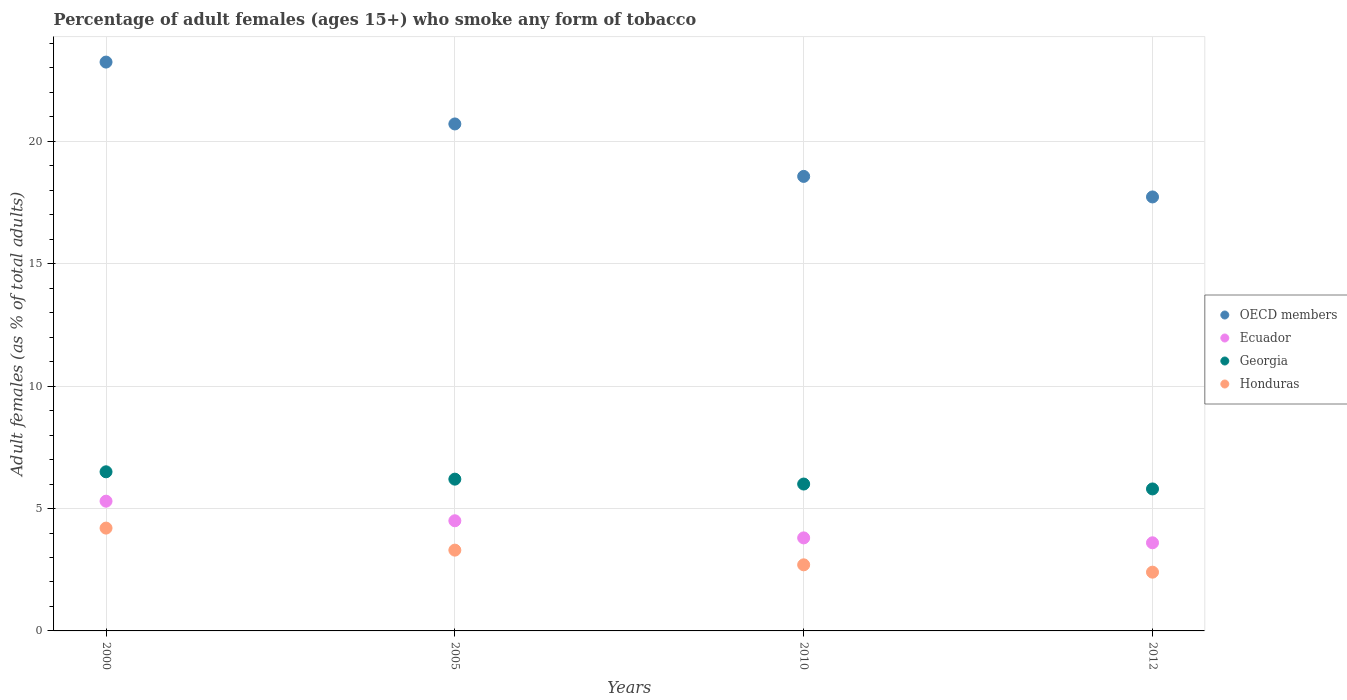How many different coloured dotlines are there?
Offer a terse response. 4. What is the percentage of adult females who smoke in Ecuador in 2010?
Ensure brevity in your answer.  3.8. Across all years, what is the minimum percentage of adult females who smoke in Honduras?
Ensure brevity in your answer.  2.4. In which year was the percentage of adult females who smoke in Honduras maximum?
Provide a short and direct response. 2000. In which year was the percentage of adult females who smoke in Ecuador minimum?
Ensure brevity in your answer.  2012. What is the total percentage of adult females who smoke in OECD members in the graph?
Offer a very short reply. 80.24. What is the difference between the percentage of adult females who smoke in Ecuador in 2000 and that in 2005?
Your response must be concise. 0.8. What is the difference between the percentage of adult females who smoke in OECD members in 2005 and the percentage of adult females who smoke in Ecuador in 2012?
Your answer should be compact. 17.11. What is the average percentage of adult females who smoke in Honduras per year?
Provide a short and direct response. 3.15. In the year 2012, what is the difference between the percentage of adult females who smoke in Ecuador and percentage of adult females who smoke in Georgia?
Give a very brief answer. -2.2. What is the ratio of the percentage of adult females who smoke in Honduras in 2010 to that in 2012?
Provide a succinct answer. 1.13. Is the percentage of adult females who smoke in Georgia in 2010 less than that in 2012?
Give a very brief answer. No. Is the difference between the percentage of adult females who smoke in Ecuador in 2005 and 2010 greater than the difference between the percentage of adult females who smoke in Georgia in 2005 and 2010?
Provide a short and direct response. Yes. What is the difference between the highest and the second highest percentage of adult females who smoke in Ecuador?
Give a very brief answer. 0.8. What is the difference between the highest and the lowest percentage of adult females who smoke in Georgia?
Your answer should be compact. 0.7. In how many years, is the percentage of adult females who smoke in OECD members greater than the average percentage of adult females who smoke in OECD members taken over all years?
Your response must be concise. 2. Is the sum of the percentage of adult females who smoke in Ecuador in 2005 and 2012 greater than the maximum percentage of adult females who smoke in Georgia across all years?
Your answer should be compact. Yes. Is it the case that in every year, the sum of the percentage of adult females who smoke in Honduras and percentage of adult females who smoke in Ecuador  is greater than the sum of percentage of adult females who smoke in OECD members and percentage of adult females who smoke in Georgia?
Make the answer very short. No. Is the percentage of adult females who smoke in Honduras strictly greater than the percentage of adult females who smoke in Ecuador over the years?
Ensure brevity in your answer.  No. Is the percentage of adult females who smoke in Honduras strictly less than the percentage of adult females who smoke in Ecuador over the years?
Your answer should be very brief. Yes. How many years are there in the graph?
Your answer should be very brief. 4. What is the difference between two consecutive major ticks on the Y-axis?
Your answer should be very brief. 5. Does the graph contain grids?
Your answer should be compact. Yes. How are the legend labels stacked?
Your response must be concise. Vertical. What is the title of the graph?
Provide a succinct answer. Percentage of adult females (ages 15+) who smoke any form of tobacco. What is the label or title of the X-axis?
Make the answer very short. Years. What is the label or title of the Y-axis?
Your answer should be very brief. Adult females (as % of total adults). What is the Adult females (as % of total adults) of OECD members in 2000?
Give a very brief answer. 23.24. What is the Adult females (as % of total adults) of Honduras in 2000?
Ensure brevity in your answer.  4.2. What is the Adult females (as % of total adults) of OECD members in 2005?
Offer a terse response. 20.71. What is the Adult females (as % of total adults) in Ecuador in 2005?
Provide a succinct answer. 4.5. What is the Adult females (as % of total adults) of Georgia in 2005?
Offer a terse response. 6.2. What is the Adult females (as % of total adults) in OECD members in 2010?
Your response must be concise. 18.57. What is the Adult females (as % of total adults) in Georgia in 2010?
Provide a succinct answer. 6. What is the Adult females (as % of total adults) of Honduras in 2010?
Provide a succinct answer. 2.7. What is the Adult females (as % of total adults) of OECD members in 2012?
Offer a very short reply. 17.73. What is the Adult females (as % of total adults) of Georgia in 2012?
Provide a short and direct response. 5.8. Across all years, what is the maximum Adult females (as % of total adults) of OECD members?
Provide a short and direct response. 23.24. Across all years, what is the maximum Adult females (as % of total adults) of Ecuador?
Your response must be concise. 5.3. Across all years, what is the minimum Adult females (as % of total adults) of OECD members?
Offer a very short reply. 17.73. Across all years, what is the minimum Adult females (as % of total adults) of Honduras?
Keep it short and to the point. 2.4. What is the total Adult females (as % of total adults) in OECD members in the graph?
Offer a terse response. 80.24. What is the total Adult females (as % of total adults) in Honduras in the graph?
Provide a succinct answer. 12.6. What is the difference between the Adult females (as % of total adults) of OECD members in 2000 and that in 2005?
Provide a short and direct response. 2.53. What is the difference between the Adult females (as % of total adults) of Ecuador in 2000 and that in 2005?
Offer a terse response. 0.8. What is the difference between the Adult females (as % of total adults) of OECD members in 2000 and that in 2010?
Give a very brief answer. 4.67. What is the difference between the Adult females (as % of total adults) of Ecuador in 2000 and that in 2010?
Your response must be concise. 1.5. What is the difference between the Adult females (as % of total adults) of Georgia in 2000 and that in 2010?
Your answer should be compact. 0.5. What is the difference between the Adult females (as % of total adults) of OECD members in 2000 and that in 2012?
Keep it short and to the point. 5.51. What is the difference between the Adult females (as % of total adults) of Honduras in 2000 and that in 2012?
Offer a very short reply. 1.8. What is the difference between the Adult females (as % of total adults) of OECD members in 2005 and that in 2010?
Ensure brevity in your answer.  2.14. What is the difference between the Adult females (as % of total adults) in Georgia in 2005 and that in 2010?
Ensure brevity in your answer.  0.2. What is the difference between the Adult females (as % of total adults) in OECD members in 2005 and that in 2012?
Make the answer very short. 2.98. What is the difference between the Adult females (as % of total adults) of Ecuador in 2005 and that in 2012?
Provide a succinct answer. 0.9. What is the difference between the Adult females (as % of total adults) in Georgia in 2005 and that in 2012?
Offer a terse response. 0.4. What is the difference between the Adult females (as % of total adults) in OECD members in 2010 and that in 2012?
Your answer should be compact. 0.84. What is the difference between the Adult females (as % of total adults) in Ecuador in 2010 and that in 2012?
Give a very brief answer. 0.2. What is the difference between the Adult females (as % of total adults) of OECD members in 2000 and the Adult females (as % of total adults) of Ecuador in 2005?
Your answer should be compact. 18.74. What is the difference between the Adult females (as % of total adults) in OECD members in 2000 and the Adult females (as % of total adults) in Georgia in 2005?
Offer a terse response. 17.04. What is the difference between the Adult females (as % of total adults) of OECD members in 2000 and the Adult females (as % of total adults) of Honduras in 2005?
Provide a short and direct response. 19.94. What is the difference between the Adult females (as % of total adults) of Ecuador in 2000 and the Adult females (as % of total adults) of Honduras in 2005?
Your answer should be compact. 2. What is the difference between the Adult females (as % of total adults) of OECD members in 2000 and the Adult females (as % of total adults) of Ecuador in 2010?
Your answer should be compact. 19.44. What is the difference between the Adult females (as % of total adults) in OECD members in 2000 and the Adult females (as % of total adults) in Georgia in 2010?
Offer a terse response. 17.24. What is the difference between the Adult females (as % of total adults) of OECD members in 2000 and the Adult females (as % of total adults) of Honduras in 2010?
Your answer should be compact. 20.54. What is the difference between the Adult females (as % of total adults) of Ecuador in 2000 and the Adult females (as % of total adults) of Honduras in 2010?
Give a very brief answer. 2.6. What is the difference between the Adult females (as % of total adults) of OECD members in 2000 and the Adult females (as % of total adults) of Ecuador in 2012?
Offer a very short reply. 19.64. What is the difference between the Adult females (as % of total adults) of OECD members in 2000 and the Adult females (as % of total adults) of Georgia in 2012?
Keep it short and to the point. 17.44. What is the difference between the Adult females (as % of total adults) in OECD members in 2000 and the Adult females (as % of total adults) in Honduras in 2012?
Your response must be concise. 20.84. What is the difference between the Adult females (as % of total adults) of Ecuador in 2000 and the Adult females (as % of total adults) of Georgia in 2012?
Your answer should be compact. -0.5. What is the difference between the Adult females (as % of total adults) in Ecuador in 2000 and the Adult females (as % of total adults) in Honduras in 2012?
Give a very brief answer. 2.9. What is the difference between the Adult females (as % of total adults) in Georgia in 2000 and the Adult females (as % of total adults) in Honduras in 2012?
Offer a terse response. 4.1. What is the difference between the Adult females (as % of total adults) in OECD members in 2005 and the Adult females (as % of total adults) in Ecuador in 2010?
Keep it short and to the point. 16.91. What is the difference between the Adult females (as % of total adults) in OECD members in 2005 and the Adult females (as % of total adults) in Georgia in 2010?
Keep it short and to the point. 14.71. What is the difference between the Adult females (as % of total adults) of OECD members in 2005 and the Adult females (as % of total adults) of Honduras in 2010?
Your response must be concise. 18.01. What is the difference between the Adult females (as % of total adults) in Ecuador in 2005 and the Adult females (as % of total adults) in Georgia in 2010?
Make the answer very short. -1.5. What is the difference between the Adult females (as % of total adults) in Georgia in 2005 and the Adult females (as % of total adults) in Honduras in 2010?
Give a very brief answer. 3.5. What is the difference between the Adult females (as % of total adults) of OECD members in 2005 and the Adult females (as % of total adults) of Ecuador in 2012?
Make the answer very short. 17.11. What is the difference between the Adult females (as % of total adults) of OECD members in 2005 and the Adult females (as % of total adults) of Georgia in 2012?
Provide a short and direct response. 14.91. What is the difference between the Adult females (as % of total adults) of OECD members in 2005 and the Adult females (as % of total adults) of Honduras in 2012?
Offer a very short reply. 18.31. What is the difference between the Adult females (as % of total adults) of OECD members in 2010 and the Adult females (as % of total adults) of Ecuador in 2012?
Offer a very short reply. 14.97. What is the difference between the Adult females (as % of total adults) in OECD members in 2010 and the Adult females (as % of total adults) in Georgia in 2012?
Provide a short and direct response. 12.77. What is the difference between the Adult females (as % of total adults) in OECD members in 2010 and the Adult females (as % of total adults) in Honduras in 2012?
Keep it short and to the point. 16.17. What is the difference between the Adult females (as % of total adults) in Ecuador in 2010 and the Adult females (as % of total adults) in Georgia in 2012?
Ensure brevity in your answer.  -2. What is the difference between the Adult females (as % of total adults) of Ecuador in 2010 and the Adult females (as % of total adults) of Honduras in 2012?
Provide a short and direct response. 1.4. What is the difference between the Adult females (as % of total adults) in Georgia in 2010 and the Adult females (as % of total adults) in Honduras in 2012?
Provide a short and direct response. 3.6. What is the average Adult females (as % of total adults) in OECD members per year?
Make the answer very short. 20.06. What is the average Adult females (as % of total adults) of Ecuador per year?
Provide a short and direct response. 4.3. What is the average Adult females (as % of total adults) in Georgia per year?
Offer a terse response. 6.12. What is the average Adult females (as % of total adults) in Honduras per year?
Keep it short and to the point. 3.15. In the year 2000, what is the difference between the Adult females (as % of total adults) of OECD members and Adult females (as % of total adults) of Ecuador?
Make the answer very short. 17.94. In the year 2000, what is the difference between the Adult females (as % of total adults) in OECD members and Adult females (as % of total adults) in Georgia?
Your response must be concise. 16.74. In the year 2000, what is the difference between the Adult females (as % of total adults) in OECD members and Adult females (as % of total adults) in Honduras?
Offer a terse response. 19.04. In the year 2000, what is the difference between the Adult females (as % of total adults) in Ecuador and Adult females (as % of total adults) in Georgia?
Provide a short and direct response. -1.2. In the year 2005, what is the difference between the Adult females (as % of total adults) in OECD members and Adult females (as % of total adults) in Ecuador?
Make the answer very short. 16.21. In the year 2005, what is the difference between the Adult females (as % of total adults) in OECD members and Adult females (as % of total adults) in Georgia?
Ensure brevity in your answer.  14.51. In the year 2005, what is the difference between the Adult females (as % of total adults) of OECD members and Adult females (as % of total adults) of Honduras?
Provide a succinct answer. 17.41. In the year 2005, what is the difference between the Adult females (as % of total adults) in Ecuador and Adult females (as % of total adults) in Georgia?
Your response must be concise. -1.7. In the year 2005, what is the difference between the Adult females (as % of total adults) of Georgia and Adult females (as % of total adults) of Honduras?
Your answer should be compact. 2.9. In the year 2010, what is the difference between the Adult females (as % of total adults) in OECD members and Adult females (as % of total adults) in Ecuador?
Keep it short and to the point. 14.77. In the year 2010, what is the difference between the Adult females (as % of total adults) in OECD members and Adult females (as % of total adults) in Georgia?
Offer a very short reply. 12.57. In the year 2010, what is the difference between the Adult females (as % of total adults) in OECD members and Adult females (as % of total adults) in Honduras?
Your response must be concise. 15.87. In the year 2010, what is the difference between the Adult females (as % of total adults) in Ecuador and Adult females (as % of total adults) in Georgia?
Keep it short and to the point. -2.2. In the year 2010, what is the difference between the Adult females (as % of total adults) of Ecuador and Adult females (as % of total adults) of Honduras?
Provide a succinct answer. 1.1. In the year 2012, what is the difference between the Adult females (as % of total adults) of OECD members and Adult females (as % of total adults) of Ecuador?
Provide a succinct answer. 14.13. In the year 2012, what is the difference between the Adult females (as % of total adults) in OECD members and Adult females (as % of total adults) in Georgia?
Your answer should be very brief. 11.93. In the year 2012, what is the difference between the Adult females (as % of total adults) of OECD members and Adult females (as % of total adults) of Honduras?
Keep it short and to the point. 15.33. In the year 2012, what is the difference between the Adult females (as % of total adults) in Ecuador and Adult females (as % of total adults) in Honduras?
Provide a succinct answer. 1.2. What is the ratio of the Adult females (as % of total adults) of OECD members in 2000 to that in 2005?
Provide a short and direct response. 1.12. What is the ratio of the Adult females (as % of total adults) in Ecuador in 2000 to that in 2005?
Provide a short and direct response. 1.18. What is the ratio of the Adult females (as % of total adults) of Georgia in 2000 to that in 2005?
Keep it short and to the point. 1.05. What is the ratio of the Adult females (as % of total adults) of Honduras in 2000 to that in 2005?
Offer a terse response. 1.27. What is the ratio of the Adult females (as % of total adults) of OECD members in 2000 to that in 2010?
Make the answer very short. 1.25. What is the ratio of the Adult females (as % of total adults) in Ecuador in 2000 to that in 2010?
Provide a succinct answer. 1.39. What is the ratio of the Adult females (as % of total adults) of Honduras in 2000 to that in 2010?
Provide a short and direct response. 1.56. What is the ratio of the Adult females (as % of total adults) of OECD members in 2000 to that in 2012?
Keep it short and to the point. 1.31. What is the ratio of the Adult females (as % of total adults) in Ecuador in 2000 to that in 2012?
Give a very brief answer. 1.47. What is the ratio of the Adult females (as % of total adults) of Georgia in 2000 to that in 2012?
Provide a short and direct response. 1.12. What is the ratio of the Adult females (as % of total adults) of OECD members in 2005 to that in 2010?
Your answer should be compact. 1.12. What is the ratio of the Adult females (as % of total adults) of Ecuador in 2005 to that in 2010?
Your response must be concise. 1.18. What is the ratio of the Adult females (as % of total adults) of Honduras in 2005 to that in 2010?
Keep it short and to the point. 1.22. What is the ratio of the Adult females (as % of total adults) of OECD members in 2005 to that in 2012?
Offer a terse response. 1.17. What is the ratio of the Adult females (as % of total adults) of Ecuador in 2005 to that in 2012?
Keep it short and to the point. 1.25. What is the ratio of the Adult females (as % of total adults) of Georgia in 2005 to that in 2012?
Provide a short and direct response. 1.07. What is the ratio of the Adult females (as % of total adults) in Honduras in 2005 to that in 2012?
Your answer should be very brief. 1.38. What is the ratio of the Adult females (as % of total adults) in OECD members in 2010 to that in 2012?
Offer a very short reply. 1.05. What is the ratio of the Adult females (as % of total adults) in Ecuador in 2010 to that in 2012?
Your answer should be very brief. 1.06. What is the ratio of the Adult females (as % of total adults) in Georgia in 2010 to that in 2012?
Keep it short and to the point. 1.03. What is the ratio of the Adult females (as % of total adults) in Honduras in 2010 to that in 2012?
Make the answer very short. 1.12. What is the difference between the highest and the second highest Adult females (as % of total adults) of OECD members?
Your answer should be very brief. 2.53. What is the difference between the highest and the lowest Adult females (as % of total adults) in OECD members?
Give a very brief answer. 5.51. What is the difference between the highest and the lowest Adult females (as % of total adults) of Ecuador?
Offer a very short reply. 1.7. What is the difference between the highest and the lowest Adult females (as % of total adults) in Georgia?
Offer a terse response. 0.7. 